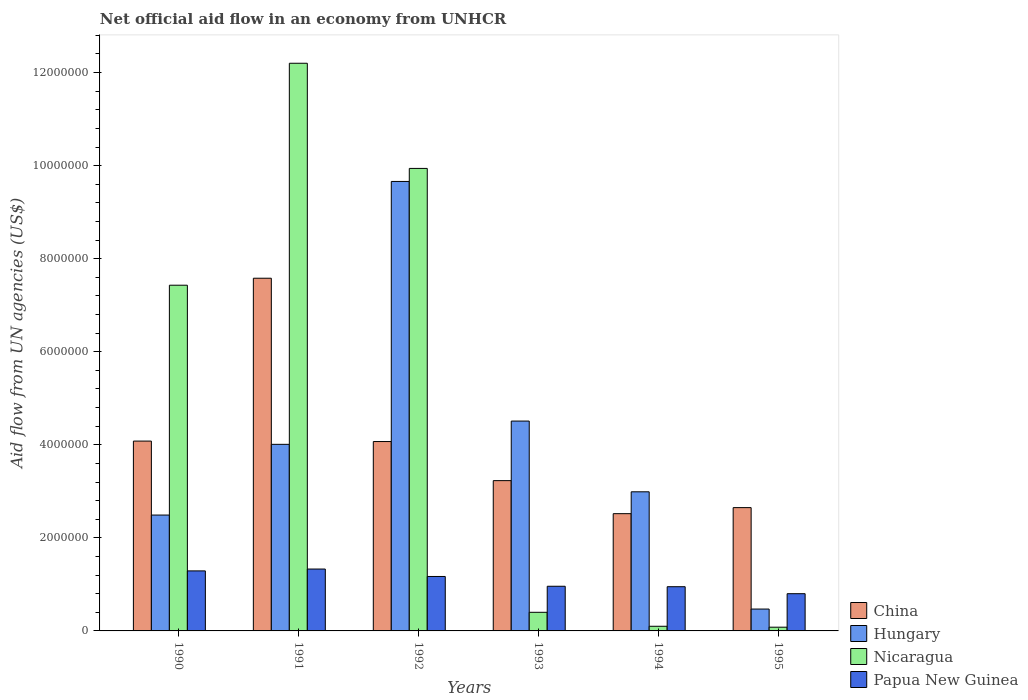How many different coloured bars are there?
Provide a succinct answer. 4. How many groups of bars are there?
Your answer should be compact. 6. Are the number of bars per tick equal to the number of legend labels?
Provide a short and direct response. Yes. Are the number of bars on each tick of the X-axis equal?
Provide a succinct answer. Yes. How many bars are there on the 6th tick from the right?
Offer a terse response. 4. What is the label of the 5th group of bars from the left?
Make the answer very short. 1994. In how many cases, is the number of bars for a given year not equal to the number of legend labels?
Your answer should be compact. 0. What is the net official aid flow in Nicaragua in 1994?
Ensure brevity in your answer.  1.00e+05. Across all years, what is the maximum net official aid flow in Hungary?
Ensure brevity in your answer.  9.66e+06. Across all years, what is the minimum net official aid flow in Papua New Guinea?
Offer a terse response. 8.00e+05. In which year was the net official aid flow in Nicaragua maximum?
Provide a short and direct response. 1991. What is the total net official aid flow in Hungary in the graph?
Your answer should be compact. 2.41e+07. What is the difference between the net official aid flow in China in 1993 and that in 1995?
Keep it short and to the point. 5.80e+05. What is the difference between the net official aid flow in Papua New Guinea in 1993 and the net official aid flow in Nicaragua in 1990?
Provide a succinct answer. -6.47e+06. What is the average net official aid flow in Nicaragua per year?
Your answer should be compact. 5.02e+06. In the year 1994, what is the difference between the net official aid flow in China and net official aid flow in Papua New Guinea?
Offer a very short reply. 1.57e+06. In how many years, is the net official aid flow in China greater than 9600000 US$?
Provide a succinct answer. 0. What is the ratio of the net official aid flow in Papua New Guinea in 1990 to that in 1993?
Your answer should be very brief. 1.34. Is the net official aid flow in China in 1994 less than that in 1995?
Make the answer very short. Yes. What is the difference between the highest and the second highest net official aid flow in China?
Offer a very short reply. 3.50e+06. What is the difference between the highest and the lowest net official aid flow in China?
Offer a terse response. 5.06e+06. What does the 2nd bar from the left in 1993 represents?
Offer a terse response. Hungary. What does the 2nd bar from the right in 1994 represents?
Your response must be concise. Nicaragua. Are all the bars in the graph horizontal?
Offer a terse response. No. How many years are there in the graph?
Make the answer very short. 6. What is the difference between two consecutive major ticks on the Y-axis?
Offer a very short reply. 2.00e+06. Are the values on the major ticks of Y-axis written in scientific E-notation?
Provide a succinct answer. No. What is the title of the graph?
Make the answer very short. Net official aid flow in an economy from UNHCR. What is the label or title of the X-axis?
Provide a short and direct response. Years. What is the label or title of the Y-axis?
Give a very brief answer. Aid flow from UN agencies (US$). What is the Aid flow from UN agencies (US$) of China in 1990?
Your answer should be very brief. 4.08e+06. What is the Aid flow from UN agencies (US$) in Hungary in 1990?
Give a very brief answer. 2.49e+06. What is the Aid flow from UN agencies (US$) of Nicaragua in 1990?
Ensure brevity in your answer.  7.43e+06. What is the Aid flow from UN agencies (US$) of Papua New Guinea in 1990?
Your answer should be very brief. 1.29e+06. What is the Aid flow from UN agencies (US$) of China in 1991?
Provide a short and direct response. 7.58e+06. What is the Aid flow from UN agencies (US$) in Hungary in 1991?
Offer a very short reply. 4.01e+06. What is the Aid flow from UN agencies (US$) in Nicaragua in 1991?
Your response must be concise. 1.22e+07. What is the Aid flow from UN agencies (US$) of Papua New Guinea in 1991?
Your answer should be very brief. 1.33e+06. What is the Aid flow from UN agencies (US$) in China in 1992?
Ensure brevity in your answer.  4.07e+06. What is the Aid flow from UN agencies (US$) in Hungary in 1992?
Offer a very short reply. 9.66e+06. What is the Aid flow from UN agencies (US$) in Nicaragua in 1992?
Provide a succinct answer. 9.94e+06. What is the Aid flow from UN agencies (US$) of Papua New Guinea in 1992?
Provide a succinct answer. 1.17e+06. What is the Aid flow from UN agencies (US$) of China in 1993?
Make the answer very short. 3.23e+06. What is the Aid flow from UN agencies (US$) in Hungary in 1993?
Offer a terse response. 4.51e+06. What is the Aid flow from UN agencies (US$) of Nicaragua in 1993?
Your answer should be very brief. 4.00e+05. What is the Aid flow from UN agencies (US$) in Papua New Guinea in 1993?
Give a very brief answer. 9.60e+05. What is the Aid flow from UN agencies (US$) in China in 1994?
Provide a succinct answer. 2.52e+06. What is the Aid flow from UN agencies (US$) in Hungary in 1994?
Ensure brevity in your answer.  2.99e+06. What is the Aid flow from UN agencies (US$) of Nicaragua in 1994?
Offer a very short reply. 1.00e+05. What is the Aid flow from UN agencies (US$) in Papua New Guinea in 1994?
Your response must be concise. 9.50e+05. What is the Aid flow from UN agencies (US$) of China in 1995?
Your answer should be compact. 2.65e+06. What is the Aid flow from UN agencies (US$) in Hungary in 1995?
Offer a terse response. 4.70e+05. What is the Aid flow from UN agencies (US$) of Nicaragua in 1995?
Your answer should be compact. 8.00e+04. Across all years, what is the maximum Aid flow from UN agencies (US$) of China?
Make the answer very short. 7.58e+06. Across all years, what is the maximum Aid flow from UN agencies (US$) in Hungary?
Your response must be concise. 9.66e+06. Across all years, what is the maximum Aid flow from UN agencies (US$) of Nicaragua?
Give a very brief answer. 1.22e+07. Across all years, what is the maximum Aid flow from UN agencies (US$) in Papua New Guinea?
Provide a short and direct response. 1.33e+06. Across all years, what is the minimum Aid flow from UN agencies (US$) in China?
Make the answer very short. 2.52e+06. Across all years, what is the minimum Aid flow from UN agencies (US$) in Hungary?
Keep it short and to the point. 4.70e+05. Across all years, what is the minimum Aid flow from UN agencies (US$) in Nicaragua?
Give a very brief answer. 8.00e+04. Across all years, what is the minimum Aid flow from UN agencies (US$) of Papua New Guinea?
Your answer should be very brief. 8.00e+05. What is the total Aid flow from UN agencies (US$) of China in the graph?
Your answer should be very brief. 2.41e+07. What is the total Aid flow from UN agencies (US$) of Hungary in the graph?
Your answer should be compact. 2.41e+07. What is the total Aid flow from UN agencies (US$) of Nicaragua in the graph?
Provide a succinct answer. 3.02e+07. What is the total Aid flow from UN agencies (US$) in Papua New Guinea in the graph?
Your answer should be very brief. 6.50e+06. What is the difference between the Aid flow from UN agencies (US$) of China in 1990 and that in 1991?
Make the answer very short. -3.50e+06. What is the difference between the Aid flow from UN agencies (US$) of Hungary in 1990 and that in 1991?
Your answer should be very brief. -1.52e+06. What is the difference between the Aid flow from UN agencies (US$) of Nicaragua in 1990 and that in 1991?
Offer a terse response. -4.77e+06. What is the difference between the Aid flow from UN agencies (US$) of Hungary in 1990 and that in 1992?
Provide a short and direct response. -7.17e+06. What is the difference between the Aid flow from UN agencies (US$) in Nicaragua in 1990 and that in 1992?
Your response must be concise. -2.51e+06. What is the difference between the Aid flow from UN agencies (US$) in Papua New Guinea in 1990 and that in 1992?
Make the answer very short. 1.20e+05. What is the difference between the Aid flow from UN agencies (US$) in China in 1990 and that in 1993?
Your response must be concise. 8.50e+05. What is the difference between the Aid flow from UN agencies (US$) of Hungary in 1990 and that in 1993?
Ensure brevity in your answer.  -2.02e+06. What is the difference between the Aid flow from UN agencies (US$) in Nicaragua in 1990 and that in 1993?
Your answer should be compact. 7.03e+06. What is the difference between the Aid flow from UN agencies (US$) in China in 1990 and that in 1994?
Your answer should be very brief. 1.56e+06. What is the difference between the Aid flow from UN agencies (US$) of Hungary in 1990 and that in 1994?
Your response must be concise. -5.00e+05. What is the difference between the Aid flow from UN agencies (US$) of Nicaragua in 1990 and that in 1994?
Make the answer very short. 7.33e+06. What is the difference between the Aid flow from UN agencies (US$) of Papua New Guinea in 1990 and that in 1994?
Offer a very short reply. 3.40e+05. What is the difference between the Aid flow from UN agencies (US$) of China in 1990 and that in 1995?
Provide a short and direct response. 1.43e+06. What is the difference between the Aid flow from UN agencies (US$) in Hungary in 1990 and that in 1995?
Give a very brief answer. 2.02e+06. What is the difference between the Aid flow from UN agencies (US$) of Nicaragua in 1990 and that in 1995?
Make the answer very short. 7.35e+06. What is the difference between the Aid flow from UN agencies (US$) in China in 1991 and that in 1992?
Provide a succinct answer. 3.51e+06. What is the difference between the Aid flow from UN agencies (US$) of Hungary in 1991 and that in 1992?
Your answer should be compact. -5.65e+06. What is the difference between the Aid flow from UN agencies (US$) of Nicaragua in 1991 and that in 1992?
Your answer should be very brief. 2.26e+06. What is the difference between the Aid flow from UN agencies (US$) of China in 1991 and that in 1993?
Provide a short and direct response. 4.35e+06. What is the difference between the Aid flow from UN agencies (US$) in Hungary in 1991 and that in 1993?
Keep it short and to the point. -5.00e+05. What is the difference between the Aid flow from UN agencies (US$) in Nicaragua in 1991 and that in 1993?
Provide a short and direct response. 1.18e+07. What is the difference between the Aid flow from UN agencies (US$) in China in 1991 and that in 1994?
Keep it short and to the point. 5.06e+06. What is the difference between the Aid flow from UN agencies (US$) in Hungary in 1991 and that in 1994?
Provide a short and direct response. 1.02e+06. What is the difference between the Aid flow from UN agencies (US$) of Nicaragua in 1991 and that in 1994?
Make the answer very short. 1.21e+07. What is the difference between the Aid flow from UN agencies (US$) in China in 1991 and that in 1995?
Offer a very short reply. 4.93e+06. What is the difference between the Aid flow from UN agencies (US$) of Hungary in 1991 and that in 1995?
Make the answer very short. 3.54e+06. What is the difference between the Aid flow from UN agencies (US$) of Nicaragua in 1991 and that in 1995?
Make the answer very short. 1.21e+07. What is the difference between the Aid flow from UN agencies (US$) of Papua New Guinea in 1991 and that in 1995?
Your answer should be compact. 5.30e+05. What is the difference between the Aid flow from UN agencies (US$) in China in 1992 and that in 1993?
Offer a terse response. 8.40e+05. What is the difference between the Aid flow from UN agencies (US$) in Hungary in 1992 and that in 1993?
Your answer should be very brief. 5.15e+06. What is the difference between the Aid flow from UN agencies (US$) of Nicaragua in 1992 and that in 1993?
Offer a very short reply. 9.54e+06. What is the difference between the Aid flow from UN agencies (US$) of China in 1992 and that in 1994?
Keep it short and to the point. 1.55e+06. What is the difference between the Aid flow from UN agencies (US$) in Hungary in 1992 and that in 1994?
Your response must be concise. 6.67e+06. What is the difference between the Aid flow from UN agencies (US$) of Nicaragua in 1992 and that in 1994?
Your answer should be compact. 9.84e+06. What is the difference between the Aid flow from UN agencies (US$) in Papua New Guinea in 1992 and that in 1994?
Provide a succinct answer. 2.20e+05. What is the difference between the Aid flow from UN agencies (US$) of China in 1992 and that in 1995?
Provide a succinct answer. 1.42e+06. What is the difference between the Aid flow from UN agencies (US$) of Hungary in 1992 and that in 1995?
Ensure brevity in your answer.  9.19e+06. What is the difference between the Aid flow from UN agencies (US$) in Nicaragua in 1992 and that in 1995?
Provide a succinct answer. 9.86e+06. What is the difference between the Aid flow from UN agencies (US$) in China in 1993 and that in 1994?
Offer a terse response. 7.10e+05. What is the difference between the Aid flow from UN agencies (US$) in Hungary in 1993 and that in 1994?
Make the answer very short. 1.52e+06. What is the difference between the Aid flow from UN agencies (US$) of Nicaragua in 1993 and that in 1994?
Your answer should be compact. 3.00e+05. What is the difference between the Aid flow from UN agencies (US$) in China in 1993 and that in 1995?
Ensure brevity in your answer.  5.80e+05. What is the difference between the Aid flow from UN agencies (US$) of Hungary in 1993 and that in 1995?
Your answer should be compact. 4.04e+06. What is the difference between the Aid flow from UN agencies (US$) of Nicaragua in 1993 and that in 1995?
Your response must be concise. 3.20e+05. What is the difference between the Aid flow from UN agencies (US$) in China in 1994 and that in 1995?
Make the answer very short. -1.30e+05. What is the difference between the Aid flow from UN agencies (US$) in Hungary in 1994 and that in 1995?
Your answer should be very brief. 2.52e+06. What is the difference between the Aid flow from UN agencies (US$) of China in 1990 and the Aid flow from UN agencies (US$) of Nicaragua in 1991?
Your answer should be compact. -8.12e+06. What is the difference between the Aid flow from UN agencies (US$) in China in 1990 and the Aid flow from UN agencies (US$) in Papua New Guinea in 1991?
Offer a very short reply. 2.75e+06. What is the difference between the Aid flow from UN agencies (US$) in Hungary in 1990 and the Aid flow from UN agencies (US$) in Nicaragua in 1991?
Your response must be concise. -9.71e+06. What is the difference between the Aid flow from UN agencies (US$) of Hungary in 1990 and the Aid flow from UN agencies (US$) of Papua New Guinea in 1991?
Provide a succinct answer. 1.16e+06. What is the difference between the Aid flow from UN agencies (US$) of Nicaragua in 1990 and the Aid flow from UN agencies (US$) of Papua New Guinea in 1991?
Your answer should be very brief. 6.10e+06. What is the difference between the Aid flow from UN agencies (US$) of China in 1990 and the Aid flow from UN agencies (US$) of Hungary in 1992?
Offer a very short reply. -5.58e+06. What is the difference between the Aid flow from UN agencies (US$) in China in 1990 and the Aid flow from UN agencies (US$) in Nicaragua in 1992?
Your answer should be compact. -5.86e+06. What is the difference between the Aid flow from UN agencies (US$) of China in 1990 and the Aid flow from UN agencies (US$) of Papua New Guinea in 1992?
Provide a short and direct response. 2.91e+06. What is the difference between the Aid flow from UN agencies (US$) of Hungary in 1990 and the Aid flow from UN agencies (US$) of Nicaragua in 1992?
Provide a succinct answer. -7.45e+06. What is the difference between the Aid flow from UN agencies (US$) of Hungary in 1990 and the Aid flow from UN agencies (US$) of Papua New Guinea in 1992?
Provide a short and direct response. 1.32e+06. What is the difference between the Aid flow from UN agencies (US$) of Nicaragua in 1990 and the Aid flow from UN agencies (US$) of Papua New Guinea in 1992?
Provide a succinct answer. 6.26e+06. What is the difference between the Aid flow from UN agencies (US$) of China in 1990 and the Aid flow from UN agencies (US$) of Hungary in 1993?
Provide a short and direct response. -4.30e+05. What is the difference between the Aid flow from UN agencies (US$) in China in 1990 and the Aid flow from UN agencies (US$) in Nicaragua in 1993?
Your response must be concise. 3.68e+06. What is the difference between the Aid flow from UN agencies (US$) in China in 1990 and the Aid flow from UN agencies (US$) in Papua New Guinea in 1993?
Keep it short and to the point. 3.12e+06. What is the difference between the Aid flow from UN agencies (US$) in Hungary in 1990 and the Aid flow from UN agencies (US$) in Nicaragua in 1993?
Your answer should be compact. 2.09e+06. What is the difference between the Aid flow from UN agencies (US$) of Hungary in 1990 and the Aid flow from UN agencies (US$) of Papua New Guinea in 1993?
Ensure brevity in your answer.  1.53e+06. What is the difference between the Aid flow from UN agencies (US$) of Nicaragua in 1990 and the Aid flow from UN agencies (US$) of Papua New Guinea in 1993?
Your response must be concise. 6.47e+06. What is the difference between the Aid flow from UN agencies (US$) of China in 1990 and the Aid flow from UN agencies (US$) of Hungary in 1994?
Your response must be concise. 1.09e+06. What is the difference between the Aid flow from UN agencies (US$) of China in 1990 and the Aid flow from UN agencies (US$) of Nicaragua in 1994?
Your answer should be very brief. 3.98e+06. What is the difference between the Aid flow from UN agencies (US$) in China in 1990 and the Aid flow from UN agencies (US$) in Papua New Guinea in 1994?
Make the answer very short. 3.13e+06. What is the difference between the Aid flow from UN agencies (US$) in Hungary in 1990 and the Aid flow from UN agencies (US$) in Nicaragua in 1994?
Give a very brief answer. 2.39e+06. What is the difference between the Aid flow from UN agencies (US$) of Hungary in 1990 and the Aid flow from UN agencies (US$) of Papua New Guinea in 1994?
Offer a very short reply. 1.54e+06. What is the difference between the Aid flow from UN agencies (US$) in Nicaragua in 1990 and the Aid flow from UN agencies (US$) in Papua New Guinea in 1994?
Provide a succinct answer. 6.48e+06. What is the difference between the Aid flow from UN agencies (US$) of China in 1990 and the Aid flow from UN agencies (US$) of Hungary in 1995?
Your answer should be very brief. 3.61e+06. What is the difference between the Aid flow from UN agencies (US$) of China in 1990 and the Aid flow from UN agencies (US$) of Papua New Guinea in 1995?
Offer a terse response. 3.28e+06. What is the difference between the Aid flow from UN agencies (US$) of Hungary in 1990 and the Aid flow from UN agencies (US$) of Nicaragua in 1995?
Offer a very short reply. 2.41e+06. What is the difference between the Aid flow from UN agencies (US$) in Hungary in 1990 and the Aid flow from UN agencies (US$) in Papua New Guinea in 1995?
Ensure brevity in your answer.  1.69e+06. What is the difference between the Aid flow from UN agencies (US$) in Nicaragua in 1990 and the Aid flow from UN agencies (US$) in Papua New Guinea in 1995?
Offer a very short reply. 6.63e+06. What is the difference between the Aid flow from UN agencies (US$) of China in 1991 and the Aid flow from UN agencies (US$) of Hungary in 1992?
Ensure brevity in your answer.  -2.08e+06. What is the difference between the Aid flow from UN agencies (US$) in China in 1991 and the Aid flow from UN agencies (US$) in Nicaragua in 1992?
Ensure brevity in your answer.  -2.36e+06. What is the difference between the Aid flow from UN agencies (US$) in China in 1991 and the Aid flow from UN agencies (US$) in Papua New Guinea in 1992?
Your answer should be compact. 6.41e+06. What is the difference between the Aid flow from UN agencies (US$) in Hungary in 1991 and the Aid flow from UN agencies (US$) in Nicaragua in 1992?
Make the answer very short. -5.93e+06. What is the difference between the Aid flow from UN agencies (US$) in Hungary in 1991 and the Aid flow from UN agencies (US$) in Papua New Guinea in 1992?
Ensure brevity in your answer.  2.84e+06. What is the difference between the Aid flow from UN agencies (US$) in Nicaragua in 1991 and the Aid flow from UN agencies (US$) in Papua New Guinea in 1992?
Provide a succinct answer. 1.10e+07. What is the difference between the Aid flow from UN agencies (US$) in China in 1991 and the Aid flow from UN agencies (US$) in Hungary in 1993?
Provide a short and direct response. 3.07e+06. What is the difference between the Aid flow from UN agencies (US$) in China in 1991 and the Aid flow from UN agencies (US$) in Nicaragua in 1993?
Offer a terse response. 7.18e+06. What is the difference between the Aid flow from UN agencies (US$) in China in 1991 and the Aid flow from UN agencies (US$) in Papua New Guinea in 1993?
Keep it short and to the point. 6.62e+06. What is the difference between the Aid flow from UN agencies (US$) in Hungary in 1991 and the Aid flow from UN agencies (US$) in Nicaragua in 1993?
Provide a short and direct response. 3.61e+06. What is the difference between the Aid flow from UN agencies (US$) in Hungary in 1991 and the Aid flow from UN agencies (US$) in Papua New Guinea in 1993?
Your answer should be compact. 3.05e+06. What is the difference between the Aid flow from UN agencies (US$) of Nicaragua in 1991 and the Aid flow from UN agencies (US$) of Papua New Guinea in 1993?
Your answer should be compact. 1.12e+07. What is the difference between the Aid flow from UN agencies (US$) of China in 1991 and the Aid flow from UN agencies (US$) of Hungary in 1994?
Offer a terse response. 4.59e+06. What is the difference between the Aid flow from UN agencies (US$) of China in 1991 and the Aid flow from UN agencies (US$) of Nicaragua in 1994?
Make the answer very short. 7.48e+06. What is the difference between the Aid flow from UN agencies (US$) in China in 1991 and the Aid flow from UN agencies (US$) in Papua New Guinea in 1994?
Keep it short and to the point. 6.63e+06. What is the difference between the Aid flow from UN agencies (US$) in Hungary in 1991 and the Aid flow from UN agencies (US$) in Nicaragua in 1994?
Your response must be concise. 3.91e+06. What is the difference between the Aid flow from UN agencies (US$) in Hungary in 1991 and the Aid flow from UN agencies (US$) in Papua New Guinea in 1994?
Offer a terse response. 3.06e+06. What is the difference between the Aid flow from UN agencies (US$) of Nicaragua in 1991 and the Aid flow from UN agencies (US$) of Papua New Guinea in 1994?
Offer a very short reply. 1.12e+07. What is the difference between the Aid flow from UN agencies (US$) of China in 1991 and the Aid flow from UN agencies (US$) of Hungary in 1995?
Keep it short and to the point. 7.11e+06. What is the difference between the Aid flow from UN agencies (US$) of China in 1991 and the Aid flow from UN agencies (US$) of Nicaragua in 1995?
Give a very brief answer. 7.50e+06. What is the difference between the Aid flow from UN agencies (US$) in China in 1991 and the Aid flow from UN agencies (US$) in Papua New Guinea in 1995?
Your response must be concise. 6.78e+06. What is the difference between the Aid flow from UN agencies (US$) of Hungary in 1991 and the Aid flow from UN agencies (US$) of Nicaragua in 1995?
Make the answer very short. 3.93e+06. What is the difference between the Aid flow from UN agencies (US$) of Hungary in 1991 and the Aid flow from UN agencies (US$) of Papua New Guinea in 1995?
Provide a short and direct response. 3.21e+06. What is the difference between the Aid flow from UN agencies (US$) in Nicaragua in 1991 and the Aid flow from UN agencies (US$) in Papua New Guinea in 1995?
Give a very brief answer. 1.14e+07. What is the difference between the Aid flow from UN agencies (US$) of China in 1992 and the Aid flow from UN agencies (US$) of Hungary in 1993?
Your response must be concise. -4.40e+05. What is the difference between the Aid flow from UN agencies (US$) of China in 1992 and the Aid flow from UN agencies (US$) of Nicaragua in 1993?
Your answer should be very brief. 3.67e+06. What is the difference between the Aid flow from UN agencies (US$) of China in 1992 and the Aid flow from UN agencies (US$) of Papua New Guinea in 1993?
Your answer should be very brief. 3.11e+06. What is the difference between the Aid flow from UN agencies (US$) in Hungary in 1992 and the Aid flow from UN agencies (US$) in Nicaragua in 1993?
Provide a succinct answer. 9.26e+06. What is the difference between the Aid flow from UN agencies (US$) in Hungary in 1992 and the Aid flow from UN agencies (US$) in Papua New Guinea in 1993?
Your answer should be compact. 8.70e+06. What is the difference between the Aid flow from UN agencies (US$) in Nicaragua in 1992 and the Aid flow from UN agencies (US$) in Papua New Guinea in 1993?
Provide a succinct answer. 8.98e+06. What is the difference between the Aid flow from UN agencies (US$) of China in 1992 and the Aid flow from UN agencies (US$) of Hungary in 1994?
Make the answer very short. 1.08e+06. What is the difference between the Aid flow from UN agencies (US$) in China in 1992 and the Aid flow from UN agencies (US$) in Nicaragua in 1994?
Ensure brevity in your answer.  3.97e+06. What is the difference between the Aid flow from UN agencies (US$) of China in 1992 and the Aid flow from UN agencies (US$) of Papua New Guinea in 1994?
Make the answer very short. 3.12e+06. What is the difference between the Aid flow from UN agencies (US$) in Hungary in 1992 and the Aid flow from UN agencies (US$) in Nicaragua in 1994?
Offer a terse response. 9.56e+06. What is the difference between the Aid flow from UN agencies (US$) in Hungary in 1992 and the Aid flow from UN agencies (US$) in Papua New Guinea in 1994?
Your answer should be compact. 8.71e+06. What is the difference between the Aid flow from UN agencies (US$) in Nicaragua in 1992 and the Aid flow from UN agencies (US$) in Papua New Guinea in 1994?
Your answer should be very brief. 8.99e+06. What is the difference between the Aid flow from UN agencies (US$) in China in 1992 and the Aid flow from UN agencies (US$) in Hungary in 1995?
Your answer should be very brief. 3.60e+06. What is the difference between the Aid flow from UN agencies (US$) of China in 1992 and the Aid flow from UN agencies (US$) of Nicaragua in 1995?
Keep it short and to the point. 3.99e+06. What is the difference between the Aid flow from UN agencies (US$) in China in 1992 and the Aid flow from UN agencies (US$) in Papua New Guinea in 1995?
Offer a terse response. 3.27e+06. What is the difference between the Aid flow from UN agencies (US$) of Hungary in 1992 and the Aid flow from UN agencies (US$) of Nicaragua in 1995?
Your answer should be very brief. 9.58e+06. What is the difference between the Aid flow from UN agencies (US$) in Hungary in 1992 and the Aid flow from UN agencies (US$) in Papua New Guinea in 1995?
Ensure brevity in your answer.  8.86e+06. What is the difference between the Aid flow from UN agencies (US$) of Nicaragua in 1992 and the Aid flow from UN agencies (US$) of Papua New Guinea in 1995?
Give a very brief answer. 9.14e+06. What is the difference between the Aid flow from UN agencies (US$) of China in 1993 and the Aid flow from UN agencies (US$) of Nicaragua in 1994?
Keep it short and to the point. 3.13e+06. What is the difference between the Aid flow from UN agencies (US$) in China in 1993 and the Aid flow from UN agencies (US$) in Papua New Guinea in 1994?
Your answer should be compact. 2.28e+06. What is the difference between the Aid flow from UN agencies (US$) of Hungary in 1993 and the Aid flow from UN agencies (US$) of Nicaragua in 1994?
Offer a very short reply. 4.41e+06. What is the difference between the Aid flow from UN agencies (US$) in Hungary in 1993 and the Aid flow from UN agencies (US$) in Papua New Guinea in 1994?
Provide a short and direct response. 3.56e+06. What is the difference between the Aid flow from UN agencies (US$) in Nicaragua in 1993 and the Aid flow from UN agencies (US$) in Papua New Guinea in 1994?
Give a very brief answer. -5.50e+05. What is the difference between the Aid flow from UN agencies (US$) of China in 1993 and the Aid flow from UN agencies (US$) of Hungary in 1995?
Provide a short and direct response. 2.76e+06. What is the difference between the Aid flow from UN agencies (US$) in China in 1993 and the Aid flow from UN agencies (US$) in Nicaragua in 1995?
Keep it short and to the point. 3.15e+06. What is the difference between the Aid flow from UN agencies (US$) of China in 1993 and the Aid flow from UN agencies (US$) of Papua New Guinea in 1995?
Make the answer very short. 2.43e+06. What is the difference between the Aid flow from UN agencies (US$) of Hungary in 1993 and the Aid flow from UN agencies (US$) of Nicaragua in 1995?
Make the answer very short. 4.43e+06. What is the difference between the Aid flow from UN agencies (US$) of Hungary in 1993 and the Aid flow from UN agencies (US$) of Papua New Guinea in 1995?
Your response must be concise. 3.71e+06. What is the difference between the Aid flow from UN agencies (US$) of Nicaragua in 1993 and the Aid flow from UN agencies (US$) of Papua New Guinea in 1995?
Provide a short and direct response. -4.00e+05. What is the difference between the Aid flow from UN agencies (US$) in China in 1994 and the Aid flow from UN agencies (US$) in Hungary in 1995?
Your answer should be compact. 2.05e+06. What is the difference between the Aid flow from UN agencies (US$) in China in 1994 and the Aid flow from UN agencies (US$) in Nicaragua in 1995?
Provide a succinct answer. 2.44e+06. What is the difference between the Aid flow from UN agencies (US$) in China in 1994 and the Aid flow from UN agencies (US$) in Papua New Guinea in 1995?
Give a very brief answer. 1.72e+06. What is the difference between the Aid flow from UN agencies (US$) in Hungary in 1994 and the Aid flow from UN agencies (US$) in Nicaragua in 1995?
Make the answer very short. 2.91e+06. What is the difference between the Aid flow from UN agencies (US$) of Hungary in 1994 and the Aid flow from UN agencies (US$) of Papua New Guinea in 1995?
Ensure brevity in your answer.  2.19e+06. What is the difference between the Aid flow from UN agencies (US$) in Nicaragua in 1994 and the Aid flow from UN agencies (US$) in Papua New Guinea in 1995?
Ensure brevity in your answer.  -7.00e+05. What is the average Aid flow from UN agencies (US$) of China per year?
Offer a terse response. 4.02e+06. What is the average Aid flow from UN agencies (US$) in Hungary per year?
Your answer should be very brief. 4.02e+06. What is the average Aid flow from UN agencies (US$) of Nicaragua per year?
Keep it short and to the point. 5.02e+06. What is the average Aid flow from UN agencies (US$) in Papua New Guinea per year?
Provide a succinct answer. 1.08e+06. In the year 1990, what is the difference between the Aid flow from UN agencies (US$) in China and Aid flow from UN agencies (US$) in Hungary?
Keep it short and to the point. 1.59e+06. In the year 1990, what is the difference between the Aid flow from UN agencies (US$) of China and Aid flow from UN agencies (US$) of Nicaragua?
Ensure brevity in your answer.  -3.35e+06. In the year 1990, what is the difference between the Aid flow from UN agencies (US$) in China and Aid flow from UN agencies (US$) in Papua New Guinea?
Your answer should be compact. 2.79e+06. In the year 1990, what is the difference between the Aid flow from UN agencies (US$) in Hungary and Aid flow from UN agencies (US$) in Nicaragua?
Offer a terse response. -4.94e+06. In the year 1990, what is the difference between the Aid flow from UN agencies (US$) in Hungary and Aid flow from UN agencies (US$) in Papua New Guinea?
Provide a succinct answer. 1.20e+06. In the year 1990, what is the difference between the Aid flow from UN agencies (US$) in Nicaragua and Aid flow from UN agencies (US$) in Papua New Guinea?
Offer a terse response. 6.14e+06. In the year 1991, what is the difference between the Aid flow from UN agencies (US$) of China and Aid flow from UN agencies (US$) of Hungary?
Provide a succinct answer. 3.57e+06. In the year 1991, what is the difference between the Aid flow from UN agencies (US$) in China and Aid flow from UN agencies (US$) in Nicaragua?
Ensure brevity in your answer.  -4.62e+06. In the year 1991, what is the difference between the Aid flow from UN agencies (US$) of China and Aid flow from UN agencies (US$) of Papua New Guinea?
Offer a very short reply. 6.25e+06. In the year 1991, what is the difference between the Aid flow from UN agencies (US$) in Hungary and Aid flow from UN agencies (US$) in Nicaragua?
Provide a short and direct response. -8.19e+06. In the year 1991, what is the difference between the Aid flow from UN agencies (US$) of Hungary and Aid flow from UN agencies (US$) of Papua New Guinea?
Give a very brief answer. 2.68e+06. In the year 1991, what is the difference between the Aid flow from UN agencies (US$) of Nicaragua and Aid flow from UN agencies (US$) of Papua New Guinea?
Ensure brevity in your answer.  1.09e+07. In the year 1992, what is the difference between the Aid flow from UN agencies (US$) in China and Aid flow from UN agencies (US$) in Hungary?
Your answer should be compact. -5.59e+06. In the year 1992, what is the difference between the Aid flow from UN agencies (US$) of China and Aid flow from UN agencies (US$) of Nicaragua?
Give a very brief answer. -5.87e+06. In the year 1992, what is the difference between the Aid flow from UN agencies (US$) of China and Aid flow from UN agencies (US$) of Papua New Guinea?
Your answer should be very brief. 2.90e+06. In the year 1992, what is the difference between the Aid flow from UN agencies (US$) in Hungary and Aid flow from UN agencies (US$) in Nicaragua?
Ensure brevity in your answer.  -2.80e+05. In the year 1992, what is the difference between the Aid flow from UN agencies (US$) in Hungary and Aid flow from UN agencies (US$) in Papua New Guinea?
Your answer should be compact. 8.49e+06. In the year 1992, what is the difference between the Aid flow from UN agencies (US$) in Nicaragua and Aid flow from UN agencies (US$) in Papua New Guinea?
Provide a succinct answer. 8.77e+06. In the year 1993, what is the difference between the Aid flow from UN agencies (US$) of China and Aid flow from UN agencies (US$) of Hungary?
Ensure brevity in your answer.  -1.28e+06. In the year 1993, what is the difference between the Aid flow from UN agencies (US$) of China and Aid flow from UN agencies (US$) of Nicaragua?
Your answer should be compact. 2.83e+06. In the year 1993, what is the difference between the Aid flow from UN agencies (US$) in China and Aid flow from UN agencies (US$) in Papua New Guinea?
Offer a very short reply. 2.27e+06. In the year 1993, what is the difference between the Aid flow from UN agencies (US$) in Hungary and Aid flow from UN agencies (US$) in Nicaragua?
Offer a terse response. 4.11e+06. In the year 1993, what is the difference between the Aid flow from UN agencies (US$) in Hungary and Aid flow from UN agencies (US$) in Papua New Guinea?
Ensure brevity in your answer.  3.55e+06. In the year 1993, what is the difference between the Aid flow from UN agencies (US$) of Nicaragua and Aid flow from UN agencies (US$) of Papua New Guinea?
Provide a short and direct response. -5.60e+05. In the year 1994, what is the difference between the Aid flow from UN agencies (US$) in China and Aid flow from UN agencies (US$) in Hungary?
Provide a short and direct response. -4.70e+05. In the year 1994, what is the difference between the Aid flow from UN agencies (US$) of China and Aid flow from UN agencies (US$) of Nicaragua?
Offer a terse response. 2.42e+06. In the year 1994, what is the difference between the Aid flow from UN agencies (US$) in China and Aid flow from UN agencies (US$) in Papua New Guinea?
Provide a short and direct response. 1.57e+06. In the year 1994, what is the difference between the Aid flow from UN agencies (US$) in Hungary and Aid flow from UN agencies (US$) in Nicaragua?
Your response must be concise. 2.89e+06. In the year 1994, what is the difference between the Aid flow from UN agencies (US$) in Hungary and Aid flow from UN agencies (US$) in Papua New Guinea?
Your answer should be compact. 2.04e+06. In the year 1994, what is the difference between the Aid flow from UN agencies (US$) in Nicaragua and Aid flow from UN agencies (US$) in Papua New Guinea?
Provide a short and direct response. -8.50e+05. In the year 1995, what is the difference between the Aid flow from UN agencies (US$) of China and Aid flow from UN agencies (US$) of Hungary?
Your response must be concise. 2.18e+06. In the year 1995, what is the difference between the Aid flow from UN agencies (US$) in China and Aid flow from UN agencies (US$) in Nicaragua?
Give a very brief answer. 2.57e+06. In the year 1995, what is the difference between the Aid flow from UN agencies (US$) of China and Aid flow from UN agencies (US$) of Papua New Guinea?
Offer a very short reply. 1.85e+06. In the year 1995, what is the difference between the Aid flow from UN agencies (US$) of Hungary and Aid flow from UN agencies (US$) of Papua New Guinea?
Your answer should be compact. -3.30e+05. In the year 1995, what is the difference between the Aid flow from UN agencies (US$) of Nicaragua and Aid flow from UN agencies (US$) of Papua New Guinea?
Ensure brevity in your answer.  -7.20e+05. What is the ratio of the Aid flow from UN agencies (US$) of China in 1990 to that in 1991?
Make the answer very short. 0.54. What is the ratio of the Aid flow from UN agencies (US$) of Hungary in 1990 to that in 1991?
Ensure brevity in your answer.  0.62. What is the ratio of the Aid flow from UN agencies (US$) in Nicaragua in 1990 to that in 1991?
Your answer should be compact. 0.61. What is the ratio of the Aid flow from UN agencies (US$) in Papua New Guinea in 1990 to that in 1991?
Your response must be concise. 0.97. What is the ratio of the Aid flow from UN agencies (US$) in China in 1990 to that in 1992?
Your answer should be compact. 1. What is the ratio of the Aid flow from UN agencies (US$) in Hungary in 1990 to that in 1992?
Provide a succinct answer. 0.26. What is the ratio of the Aid flow from UN agencies (US$) of Nicaragua in 1990 to that in 1992?
Offer a very short reply. 0.75. What is the ratio of the Aid flow from UN agencies (US$) in Papua New Guinea in 1990 to that in 1992?
Offer a terse response. 1.1. What is the ratio of the Aid flow from UN agencies (US$) of China in 1990 to that in 1993?
Give a very brief answer. 1.26. What is the ratio of the Aid flow from UN agencies (US$) in Hungary in 1990 to that in 1993?
Offer a very short reply. 0.55. What is the ratio of the Aid flow from UN agencies (US$) in Nicaragua in 1990 to that in 1993?
Ensure brevity in your answer.  18.57. What is the ratio of the Aid flow from UN agencies (US$) in Papua New Guinea in 1990 to that in 1993?
Your answer should be compact. 1.34. What is the ratio of the Aid flow from UN agencies (US$) of China in 1990 to that in 1994?
Provide a short and direct response. 1.62. What is the ratio of the Aid flow from UN agencies (US$) of Hungary in 1990 to that in 1994?
Provide a short and direct response. 0.83. What is the ratio of the Aid flow from UN agencies (US$) in Nicaragua in 1990 to that in 1994?
Your answer should be compact. 74.3. What is the ratio of the Aid flow from UN agencies (US$) of Papua New Guinea in 1990 to that in 1994?
Your answer should be compact. 1.36. What is the ratio of the Aid flow from UN agencies (US$) of China in 1990 to that in 1995?
Make the answer very short. 1.54. What is the ratio of the Aid flow from UN agencies (US$) in Hungary in 1990 to that in 1995?
Provide a succinct answer. 5.3. What is the ratio of the Aid flow from UN agencies (US$) in Nicaragua in 1990 to that in 1995?
Provide a succinct answer. 92.88. What is the ratio of the Aid flow from UN agencies (US$) in Papua New Guinea in 1990 to that in 1995?
Offer a very short reply. 1.61. What is the ratio of the Aid flow from UN agencies (US$) in China in 1991 to that in 1992?
Offer a terse response. 1.86. What is the ratio of the Aid flow from UN agencies (US$) in Hungary in 1991 to that in 1992?
Make the answer very short. 0.42. What is the ratio of the Aid flow from UN agencies (US$) of Nicaragua in 1991 to that in 1992?
Ensure brevity in your answer.  1.23. What is the ratio of the Aid flow from UN agencies (US$) in Papua New Guinea in 1991 to that in 1992?
Give a very brief answer. 1.14. What is the ratio of the Aid flow from UN agencies (US$) in China in 1991 to that in 1993?
Offer a very short reply. 2.35. What is the ratio of the Aid flow from UN agencies (US$) of Hungary in 1991 to that in 1993?
Ensure brevity in your answer.  0.89. What is the ratio of the Aid flow from UN agencies (US$) of Nicaragua in 1991 to that in 1993?
Make the answer very short. 30.5. What is the ratio of the Aid flow from UN agencies (US$) of Papua New Guinea in 1991 to that in 1993?
Provide a succinct answer. 1.39. What is the ratio of the Aid flow from UN agencies (US$) in China in 1991 to that in 1994?
Your answer should be compact. 3.01. What is the ratio of the Aid flow from UN agencies (US$) in Hungary in 1991 to that in 1994?
Keep it short and to the point. 1.34. What is the ratio of the Aid flow from UN agencies (US$) of Nicaragua in 1991 to that in 1994?
Make the answer very short. 122. What is the ratio of the Aid flow from UN agencies (US$) of China in 1991 to that in 1995?
Keep it short and to the point. 2.86. What is the ratio of the Aid flow from UN agencies (US$) in Hungary in 1991 to that in 1995?
Your answer should be compact. 8.53. What is the ratio of the Aid flow from UN agencies (US$) in Nicaragua in 1991 to that in 1995?
Your response must be concise. 152.5. What is the ratio of the Aid flow from UN agencies (US$) in Papua New Guinea in 1991 to that in 1995?
Provide a succinct answer. 1.66. What is the ratio of the Aid flow from UN agencies (US$) in China in 1992 to that in 1993?
Make the answer very short. 1.26. What is the ratio of the Aid flow from UN agencies (US$) of Hungary in 1992 to that in 1993?
Provide a short and direct response. 2.14. What is the ratio of the Aid flow from UN agencies (US$) of Nicaragua in 1992 to that in 1993?
Give a very brief answer. 24.85. What is the ratio of the Aid flow from UN agencies (US$) in Papua New Guinea in 1992 to that in 1993?
Your response must be concise. 1.22. What is the ratio of the Aid flow from UN agencies (US$) of China in 1992 to that in 1994?
Offer a terse response. 1.62. What is the ratio of the Aid flow from UN agencies (US$) in Hungary in 1992 to that in 1994?
Make the answer very short. 3.23. What is the ratio of the Aid flow from UN agencies (US$) of Nicaragua in 1992 to that in 1994?
Your answer should be very brief. 99.4. What is the ratio of the Aid flow from UN agencies (US$) of Papua New Guinea in 1992 to that in 1994?
Offer a terse response. 1.23. What is the ratio of the Aid flow from UN agencies (US$) in China in 1992 to that in 1995?
Keep it short and to the point. 1.54. What is the ratio of the Aid flow from UN agencies (US$) of Hungary in 1992 to that in 1995?
Ensure brevity in your answer.  20.55. What is the ratio of the Aid flow from UN agencies (US$) of Nicaragua in 1992 to that in 1995?
Give a very brief answer. 124.25. What is the ratio of the Aid flow from UN agencies (US$) of Papua New Guinea in 1992 to that in 1995?
Provide a succinct answer. 1.46. What is the ratio of the Aid flow from UN agencies (US$) of China in 1993 to that in 1994?
Offer a terse response. 1.28. What is the ratio of the Aid flow from UN agencies (US$) of Hungary in 1993 to that in 1994?
Provide a short and direct response. 1.51. What is the ratio of the Aid flow from UN agencies (US$) in Nicaragua in 1993 to that in 1994?
Your answer should be compact. 4. What is the ratio of the Aid flow from UN agencies (US$) in Papua New Guinea in 1993 to that in 1994?
Your answer should be very brief. 1.01. What is the ratio of the Aid flow from UN agencies (US$) in China in 1993 to that in 1995?
Offer a terse response. 1.22. What is the ratio of the Aid flow from UN agencies (US$) of Hungary in 1993 to that in 1995?
Offer a very short reply. 9.6. What is the ratio of the Aid flow from UN agencies (US$) of Papua New Guinea in 1993 to that in 1995?
Offer a very short reply. 1.2. What is the ratio of the Aid flow from UN agencies (US$) of China in 1994 to that in 1995?
Give a very brief answer. 0.95. What is the ratio of the Aid flow from UN agencies (US$) in Hungary in 1994 to that in 1995?
Offer a terse response. 6.36. What is the ratio of the Aid flow from UN agencies (US$) of Papua New Guinea in 1994 to that in 1995?
Your answer should be very brief. 1.19. What is the difference between the highest and the second highest Aid flow from UN agencies (US$) of China?
Provide a succinct answer. 3.50e+06. What is the difference between the highest and the second highest Aid flow from UN agencies (US$) of Hungary?
Ensure brevity in your answer.  5.15e+06. What is the difference between the highest and the second highest Aid flow from UN agencies (US$) in Nicaragua?
Offer a terse response. 2.26e+06. What is the difference between the highest and the lowest Aid flow from UN agencies (US$) in China?
Provide a short and direct response. 5.06e+06. What is the difference between the highest and the lowest Aid flow from UN agencies (US$) of Hungary?
Your answer should be compact. 9.19e+06. What is the difference between the highest and the lowest Aid flow from UN agencies (US$) of Nicaragua?
Give a very brief answer. 1.21e+07. What is the difference between the highest and the lowest Aid flow from UN agencies (US$) in Papua New Guinea?
Offer a very short reply. 5.30e+05. 